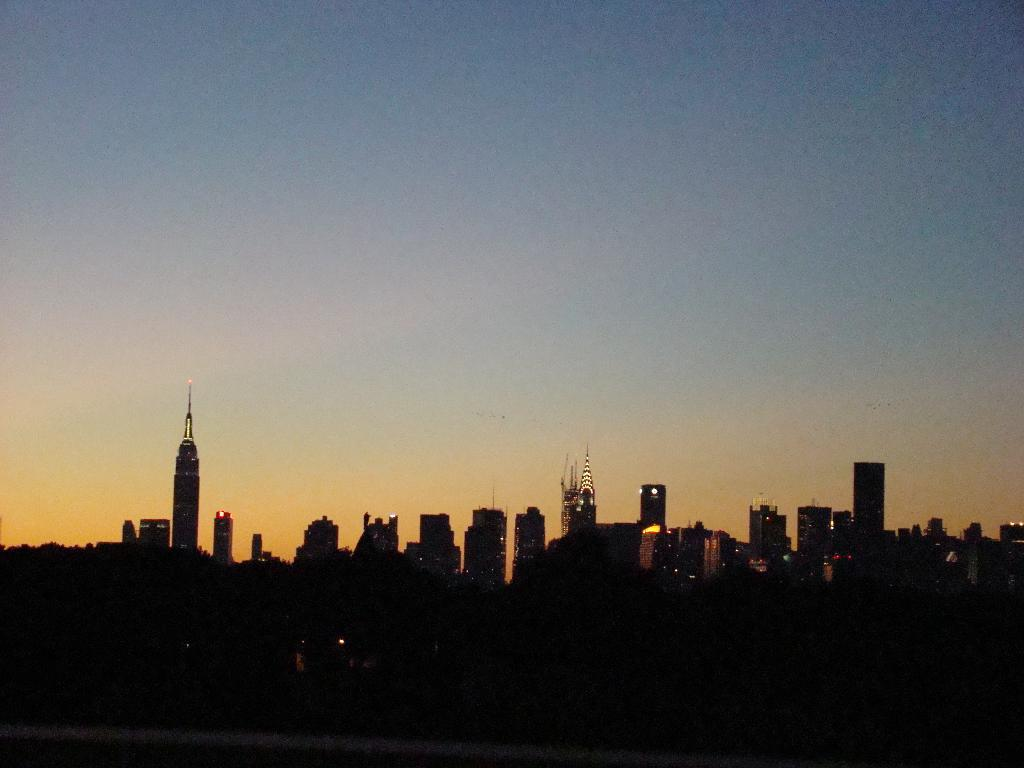What is the overall lighting condition in the image? The image is dark. What type of structures can be seen in the image? There are many buildings in the image. Are there any natural elements present in the image? Yes, there are trees in the image. How does the knot in the tree help the buildings in the image? There is no knot in the tree mentioned in the image, and therefore it cannot help the buildings. 